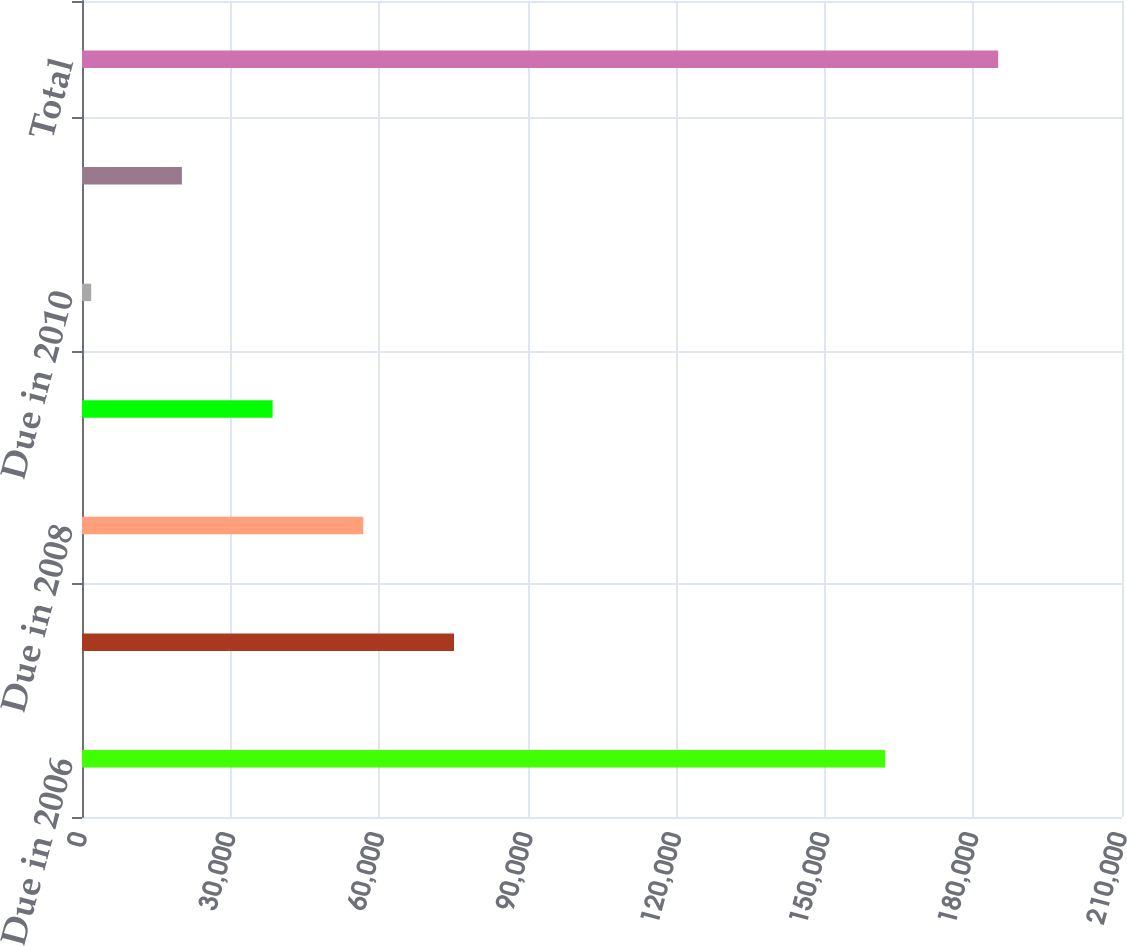<chart> <loc_0><loc_0><loc_500><loc_500><bar_chart><fcel>Due in 2006<fcel>Due in 2007<fcel>Due in 2008<fcel>Due in 2009<fcel>Due in 2010<fcel>Thereafter<fcel>Total<nl><fcel>162194<fcel>75114.6<fcel>56800.2<fcel>38485.8<fcel>1857<fcel>20171.4<fcel>185001<nl></chart> 